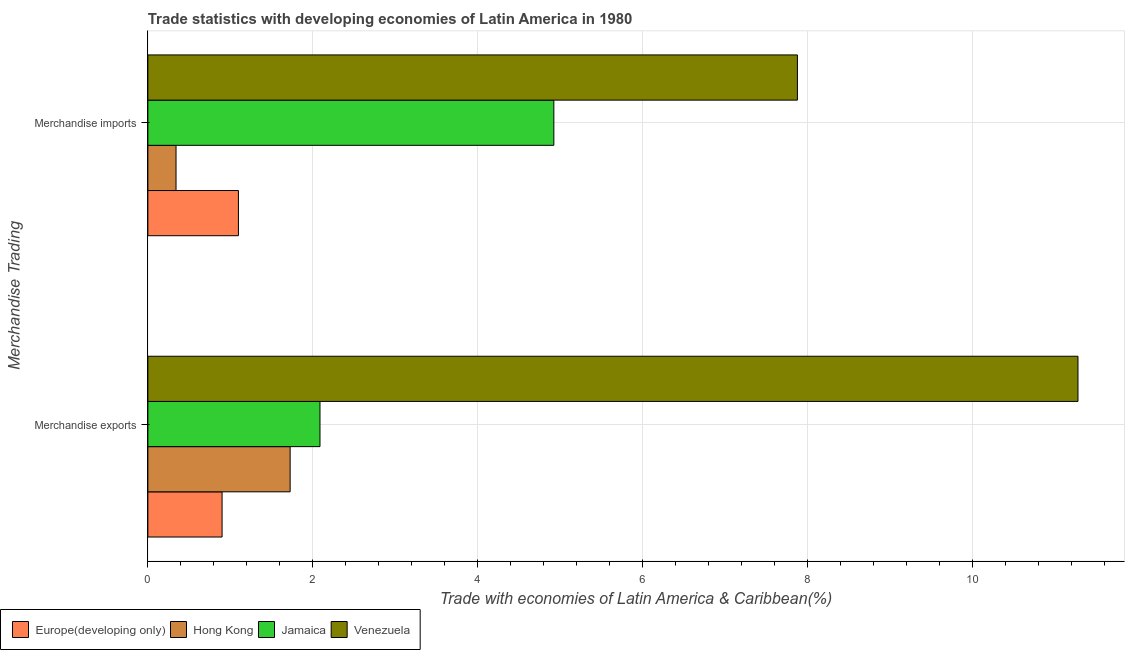How many different coloured bars are there?
Ensure brevity in your answer.  4. How many groups of bars are there?
Ensure brevity in your answer.  2. How many bars are there on the 2nd tick from the top?
Your answer should be compact. 4. How many bars are there on the 1st tick from the bottom?
Ensure brevity in your answer.  4. What is the label of the 1st group of bars from the top?
Keep it short and to the point. Merchandise imports. What is the merchandise exports in Jamaica?
Your answer should be very brief. 2.09. Across all countries, what is the maximum merchandise imports?
Your response must be concise. 7.88. Across all countries, what is the minimum merchandise exports?
Provide a short and direct response. 0.9. In which country was the merchandise exports maximum?
Provide a short and direct response. Venezuela. In which country was the merchandise exports minimum?
Make the answer very short. Europe(developing only). What is the total merchandise exports in the graph?
Ensure brevity in your answer.  15.99. What is the difference between the merchandise exports in Venezuela and that in Hong Kong?
Make the answer very short. 9.55. What is the difference between the merchandise imports in Europe(developing only) and the merchandise exports in Jamaica?
Give a very brief answer. -0.99. What is the average merchandise exports per country?
Your response must be concise. 4. What is the difference between the merchandise exports and merchandise imports in Jamaica?
Provide a succinct answer. -2.84. What is the ratio of the merchandise exports in Venezuela to that in Hong Kong?
Provide a succinct answer. 6.54. Is the merchandise imports in Europe(developing only) less than that in Venezuela?
Your answer should be very brief. Yes. In how many countries, is the merchandise exports greater than the average merchandise exports taken over all countries?
Give a very brief answer. 1. What does the 1st bar from the top in Merchandise imports represents?
Provide a succinct answer. Venezuela. What does the 1st bar from the bottom in Merchandise exports represents?
Your response must be concise. Europe(developing only). How many bars are there?
Your answer should be compact. 8. Does the graph contain any zero values?
Your answer should be compact. No. Does the graph contain grids?
Your response must be concise. Yes. How many legend labels are there?
Offer a terse response. 4. What is the title of the graph?
Keep it short and to the point. Trade statistics with developing economies of Latin America in 1980. Does "Sudan" appear as one of the legend labels in the graph?
Provide a short and direct response. No. What is the label or title of the X-axis?
Make the answer very short. Trade with economies of Latin America & Caribbean(%). What is the label or title of the Y-axis?
Your response must be concise. Merchandise Trading. What is the Trade with economies of Latin America & Caribbean(%) in Europe(developing only) in Merchandise exports?
Ensure brevity in your answer.  0.9. What is the Trade with economies of Latin America & Caribbean(%) of Hong Kong in Merchandise exports?
Your answer should be very brief. 1.73. What is the Trade with economies of Latin America & Caribbean(%) of Jamaica in Merchandise exports?
Offer a very short reply. 2.09. What is the Trade with economies of Latin America & Caribbean(%) in Venezuela in Merchandise exports?
Provide a short and direct response. 11.28. What is the Trade with economies of Latin America & Caribbean(%) in Europe(developing only) in Merchandise imports?
Provide a short and direct response. 1.1. What is the Trade with economies of Latin America & Caribbean(%) in Hong Kong in Merchandise imports?
Offer a very short reply. 0.34. What is the Trade with economies of Latin America & Caribbean(%) in Jamaica in Merchandise imports?
Your response must be concise. 4.92. What is the Trade with economies of Latin America & Caribbean(%) of Venezuela in Merchandise imports?
Provide a succinct answer. 7.88. Across all Merchandise Trading, what is the maximum Trade with economies of Latin America & Caribbean(%) in Europe(developing only)?
Keep it short and to the point. 1.1. Across all Merchandise Trading, what is the maximum Trade with economies of Latin America & Caribbean(%) of Hong Kong?
Give a very brief answer. 1.73. Across all Merchandise Trading, what is the maximum Trade with economies of Latin America & Caribbean(%) of Jamaica?
Keep it short and to the point. 4.92. Across all Merchandise Trading, what is the maximum Trade with economies of Latin America & Caribbean(%) of Venezuela?
Offer a terse response. 11.28. Across all Merchandise Trading, what is the minimum Trade with economies of Latin America & Caribbean(%) in Europe(developing only)?
Your answer should be compact. 0.9. Across all Merchandise Trading, what is the minimum Trade with economies of Latin America & Caribbean(%) in Hong Kong?
Offer a terse response. 0.34. Across all Merchandise Trading, what is the minimum Trade with economies of Latin America & Caribbean(%) of Jamaica?
Your answer should be very brief. 2.09. Across all Merchandise Trading, what is the minimum Trade with economies of Latin America & Caribbean(%) of Venezuela?
Ensure brevity in your answer.  7.88. What is the total Trade with economies of Latin America & Caribbean(%) in Europe(developing only) in the graph?
Ensure brevity in your answer.  2. What is the total Trade with economies of Latin America & Caribbean(%) in Hong Kong in the graph?
Keep it short and to the point. 2.07. What is the total Trade with economies of Latin America & Caribbean(%) in Jamaica in the graph?
Ensure brevity in your answer.  7.01. What is the total Trade with economies of Latin America & Caribbean(%) in Venezuela in the graph?
Ensure brevity in your answer.  19.16. What is the difference between the Trade with economies of Latin America & Caribbean(%) in Europe(developing only) in Merchandise exports and that in Merchandise imports?
Make the answer very short. -0.2. What is the difference between the Trade with economies of Latin America & Caribbean(%) in Hong Kong in Merchandise exports and that in Merchandise imports?
Provide a succinct answer. 1.38. What is the difference between the Trade with economies of Latin America & Caribbean(%) of Jamaica in Merchandise exports and that in Merchandise imports?
Offer a very short reply. -2.84. What is the difference between the Trade with economies of Latin America & Caribbean(%) of Venezuela in Merchandise exports and that in Merchandise imports?
Give a very brief answer. 3.4. What is the difference between the Trade with economies of Latin America & Caribbean(%) in Europe(developing only) in Merchandise exports and the Trade with economies of Latin America & Caribbean(%) in Hong Kong in Merchandise imports?
Make the answer very short. 0.56. What is the difference between the Trade with economies of Latin America & Caribbean(%) in Europe(developing only) in Merchandise exports and the Trade with economies of Latin America & Caribbean(%) in Jamaica in Merchandise imports?
Ensure brevity in your answer.  -4.02. What is the difference between the Trade with economies of Latin America & Caribbean(%) of Europe(developing only) in Merchandise exports and the Trade with economies of Latin America & Caribbean(%) of Venezuela in Merchandise imports?
Make the answer very short. -6.98. What is the difference between the Trade with economies of Latin America & Caribbean(%) of Hong Kong in Merchandise exports and the Trade with economies of Latin America & Caribbean(%) of Jamaica in Merchandise imports?
Provide a short and direct response. -3.2. What is the difference between the Trade with economies of Latin America & Caribbean(%) of Hong Kong in Merchandise exports and the Trade with economies of Latin America & Caribbean(%) of Venezuela in Merchandise imports?
Offer a terse response. -6.15. What is the difference between the Trade with economies of Latin America & Caribbean(%) of Jamaica in Merchandise exports and the Trade with economies of Latin America & Caribbean(%) of Venezuela in Merchandise imports?
Keep it short and to the point. -5.79. What is the average Trade with economies of Latin America & Caribbean(%) in Europe(developing only) per Merchandise Trading?
Your answer should be very brief. 1. What is the average Trade with economies of Latin America & Caribbean(%) of Hong Kong per Merchandise Trading?
Your response must be concise. 1.03. What is the average Trade with economies of Latin America & Caribbean(%) of Jamaica per Merchandise Trading?
Your answer should be compact. 3.51. What is the average Trade with economies of Latin America & Caribbean(%) in Venezuela per Merchandise Trading?
Provide a succinct answer. 9.58. What is the difference between the Trade with economies of Latin America & Caribbean(%) of Europe(developing only) and Trade with economies of Latin America & Caribbean(%) of Hong Kong in Merchandise exports?
Offer a very short reply. -0.83. What is the difference between the Trade with economies of Latin America & Caribbean(%) of Europe(developing only) and Trade with economies of Latin America & Caribbean(%) of Jamaica in Merchandise exports?
Your answer should be compact. -1.19. What is the difference between the Trade with economies of Latin America & Caribbean(%) in Europe(developing only) and Trade with economies of Latin America & Caribbean(%) in Venezuela in Merchandise exports?
Your answer should be compact. -10.38. What is the difference between the Trade with economies of Latin America & Caribbean(%) in Hong Kong and Trade with economies of Latin America & Caribbean(%) in Jamaica in Merchandise exports?
Make the answer very short. -0.36. What is the difference between the Trade with economies of Latin America & Caribbean(%) of Hong Kong and Trade with economies of Latin America & Caribbean(%) of Venezuela in Merchandise exports?
Keep it short and to the point. -9.55. What is the difference between the Trade with economies of Latin America & Caribbean(%) in Jamaica and Trade with economies of Latin America & Caribbean(%) in Venezuela in Merchandise exports?
Your response must be concise. -9.19. What is the difference between the Trade with economies of Latin America & Caribbean(%) of Europe(developing only) and Trade with economies of Latin America & Caribbean(%) of Hong Kong in Merchandise imports?
Keep it short and to the point. 0.76. What is the difference between the Trade with economies of Latin America & Caribbean(%) in Europe(developing only) and Trade with economies of Latin America & Caribbean(%) in Jamaica in Merchandise imports?
Your answer should be very brief. -3.83. What is the difference between the Trade with economies of Latin America & Caribbean(%) of Europe(developing only) and Trade with economies of Latin America & Caribbean(%) of Venezuela in Merchandise imports?
Offer a very short reply. -6.78. What is the difference between the Trade with economies of Latin America & Caribbean(%) of Hong Kong and Trade with economies of Latin America & Caribbean(%) of Jamaica in Merchandise imports?
Provide a short and direct response. -4.58. What is the difference between the Trade with economies of Latin America & Caribbean(%) of Hong Kong and Trade with economies of Latin America & Caribbean(%) of Venezuela in Merchandise imports?
Provide a short and direct response. -7.54. What is the difference between the Trade with economies of Latin America & Caribbean(%) of Jamaica and Trade with economies of Latin America & Caribbean(%) of Venezuela in Merchandise imports?
Your answer should be very brief. -2.95. What is the ratio of the Trade with economies of Latin America & Caribbean(%) of Europe(developing only) in Merchandise exports to that in Merchandise imports?
Give a very brief answer. 0.82. What is the ratio of the Trade with economies of Latin America & Caribbean(%) in Hong Kong in Merchandise exports to that in Merchandise imports?
Make the answer very short. 5.05. What is the ratio of the Trade with economies of Latin America & Caribbean(%) of Jamaica in Merchandise exports to that in Merchandise imports?
Provide a succinct answer. 0.42. What is the ratio of the Trade with economies of Latin America & Caribbean(%) in Venezuela in Merchandise exports to that in Merchandise imports?
Offer a very short reply. 1.43. What is the difference between the highest and the second highest Trade with economies of Latin America & Caribbean(%) of Europe(developing only)?
Your answer should be very brief. 0.2. What is the difference between the highest and the second highest Trade with economies of Latin America & Caribbean(%) in Hong Kong?
Ensure brevity in your answer.  1.38. What is the difference between the highest and the second highest Trade with economies of Latin America & Caribbean(%) of Jamaica?
Make the answer very short. 2.84. What is the difference between the highest and the second highest Trade with economies of Latin America & Caribbean(%) of Venezuela?
Your answer should be compact. 3.4. What is the difference between the highest and the lowest Trade with economies of Latin America & Caribbean(%) in Europe(developing only)?
Give a very brief answer. 0.2. What is the difference between the highest and the lowest Trade with economies of Latin America & Caribbean(%) of Hong Kong?
Ensure brevity in your answer.  1.38. What is the difference between the highest and the lowest Trade with economies of Latin America & Caribbean(%) of Jamaica?
Your response must be concise. 2.84. What is the difference between the highest and the lowest Trade with economies of Latin America & Caribbean(%) in Venezuela?
Your answer should be very brief. 3.4. 